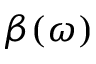<formula> <loc_0><loc_0><loc_500><loc_500>\beta ( \omega )</formula> 